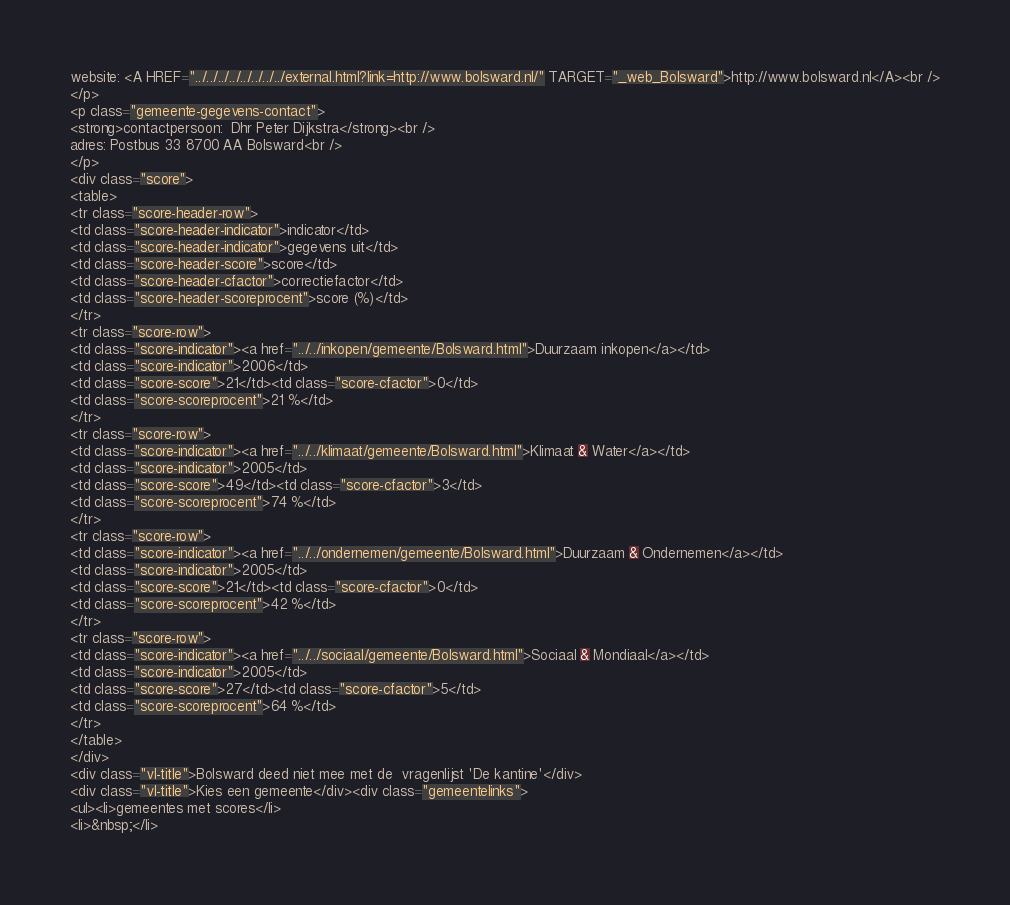Convert code to text. <code><loc_0><loc_0><loc_500><loc_500><_HTML_>website: <A HREF="../../../../../../../../external.html?link=http://www.bolsward.nl/" TARGET="_web_Bolsward">http://www.bolsward.nl</A><br />
</p>
<p class="gemeente-gegevens-contact">
<strong>contactpersoon:  Dhr Peter Dijkstra</strong><br />
adres: Postbus 33 8700 AA Bolsward<br />
</p>
<div class="score">
<table>
<tr class="score-header-row">
<td class="score-header-indicator">indicator</td>
<td class="score-header-indicator">gegevens uit</td>
<td class="score-header-score">score</td>
<td class="score-header-cfactor">correctiefactor</td>
<td class="score-header-scoreprocent">score (%)</td>
</tr>
<tr class="score-row">
<td class="score-indicator"><a href="../../inkopen/gemeente/Bolsward.html">Duurzaam inkopen</a></td>
<td class="score-indicator">2006</td>
<td class="score-score">21</td><td class="score-cfactor">0</td>
<td class="score-scoreprocent">21 %</td>
</tr>
<tr class="score-row">
<td class="score-indicator"><a href="../../klimaat/gemeente/Bolsward.html">Klimaat & Water</a></td>
<td class="score-indicator">2005</td>
<td class="score-score">49</td><td class="score-cfactor">3</td>
<td class="score-scoreprocent">74 %</td>
</tr>
<tr class="score-row">
<td class="score-indicator"><a href="../../ondernemen/gemeente/Bolsward.html">Duurzaam & Ondernemen</a></td>
<td class="score-indicator">2005</td>
<td class="score-score">21</td><td class="score-cfactor">0</td>
<td class="score-scoreprocent">42 %</td>
</tr>
<tr class="score-row">
<td class="score-indicator"><a href="../../sociaal/gemeente/Bolsward.html">Sociaal & Mondiaal</a></td>
<td class="score-indicator">2005</td>
<td class="score-score">27</td><td class="score-cfactor">5</td>
<td class="score-scoreprocent">64 %</td>
</tr>
</table>
</div>
<div class="vl-title">Bolsward deed niet mee met de  vragenlijst 'De kantine'</div>
<div class="vl-title">Kies een gemeente</div><div class="gemeentelinks">
<ul><li>gemeentes met scores</li>
<li>&nbsp;</li></code> 